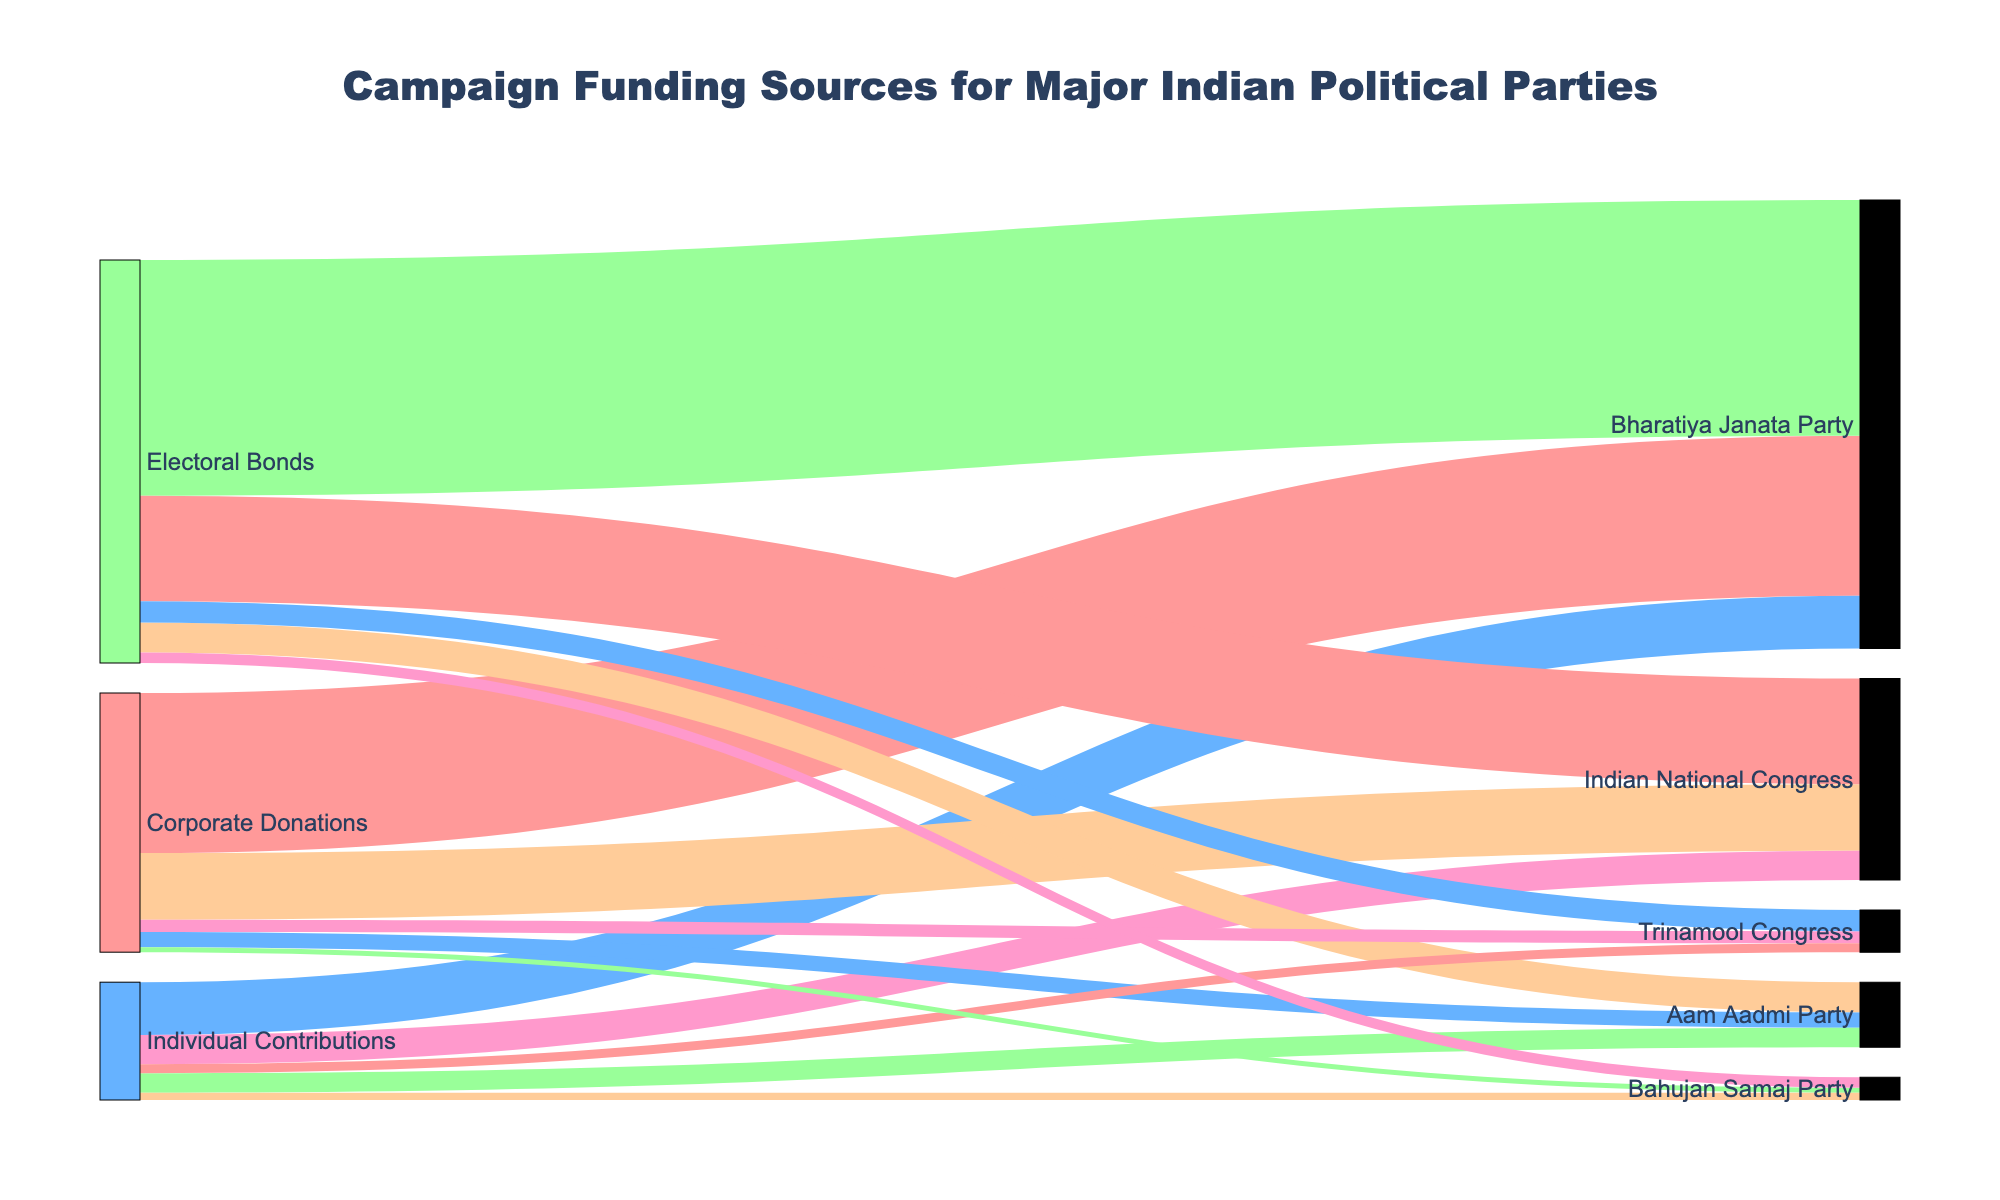What are the main sources of campaign funding depicted in the figure? The Sankey Diagram shows three main sources of campaign funding: Corporate Donations, Individual Contributions, and Electoral Bonds.
Answer: Corporate Donations, Individual Contributions, Electoral Bonds Which political party received the highest amount from corporate donations? To determine the political party receiving the most corporate donations, we look at the values flowing from "Corporate Donations" to each party. Bharatiya Janata Party received 985 Crore INR, which is higher than any other party.
Answer: Bharatiya Janata Party How much funding did the Indian National Congress receive from Electoral Bonds? Looking at the flow from "Electoral Bonds" to "Indian National Congress", the amount is 650 Crore INR.
Answer: 650 Crore INR Combine the total campaign funding for the Aam Aadmi Party. To find the total funding for Aam Aadmi Party, sum the individual amounts from Corporate Donations, Individual Contributions, and Electoral Bonds: 95 + 120 + 185. Result is 400 Crore INR.
Answer: 400 Crore INR Which party received the least funding overall? By summing the donations from all sources for each party and comparing them, Bahujan Samaj Party received the least with a total of 140 Crore INR.
Answer: Bahujan Samaj Party Compare the total contributions from Individual Contributions between Bharatiya Janata Party and Aam Aadmi Party. Bharatiya Janata Party received 325 Crore INR from Individual Contributions while Aam Aadmi Party received 120 Crore INR. Comparing these values, Bharatiya Janata Party received more.
Answer: Bharatiya Janata Party What major source of campaign funding has the highest contribution across all parties combined? Summing amounts from Corporate Donations, Individual Contributions, and Electoral Bonds: Corporate Donations (985+410+95+75+30=1595), Individual Contributions (325+180+120+55+45=725), Electoral Bonds (1450+650+185+130+65=2480). Electoral Bonds have the highest contribution.
Answer: Electoral Bonds Which party has the most diverse funding sources considering equal distribution among all three sources? To find the most balanced funding, compare the proportions from each source for each party. Aam Aadmi Party has relatively close amounts: Corporate Donations (95), Individual Contributions (120), and Electoral Bonds (185).
Answer: Aam Aadmi Party What percentage of the total Electoral Bonds funding was received by Bharatiya Janata Party? Total Electoral Bonds funding: 1450+650+185+130+65=2480 Crore INR. Bharatiya Janata Party's portion: 1450/2480 * 100 ≈ 58.47%.
Answer: 58.47% Which party received more funding from Corporate Donations compared to their funding from Electoral Bonds? Compare Corporate Donations and Electoral Bonds for each party. Both Bharatiya Janata Party (Corporate: 985, Electoral Bonds: 1450) and Indian National Congress (Corporate: 410, Electoral Bonds: 650) received less from Corporate Donations than Electoral Bonds. No party fits the criteria.
Answer: None 